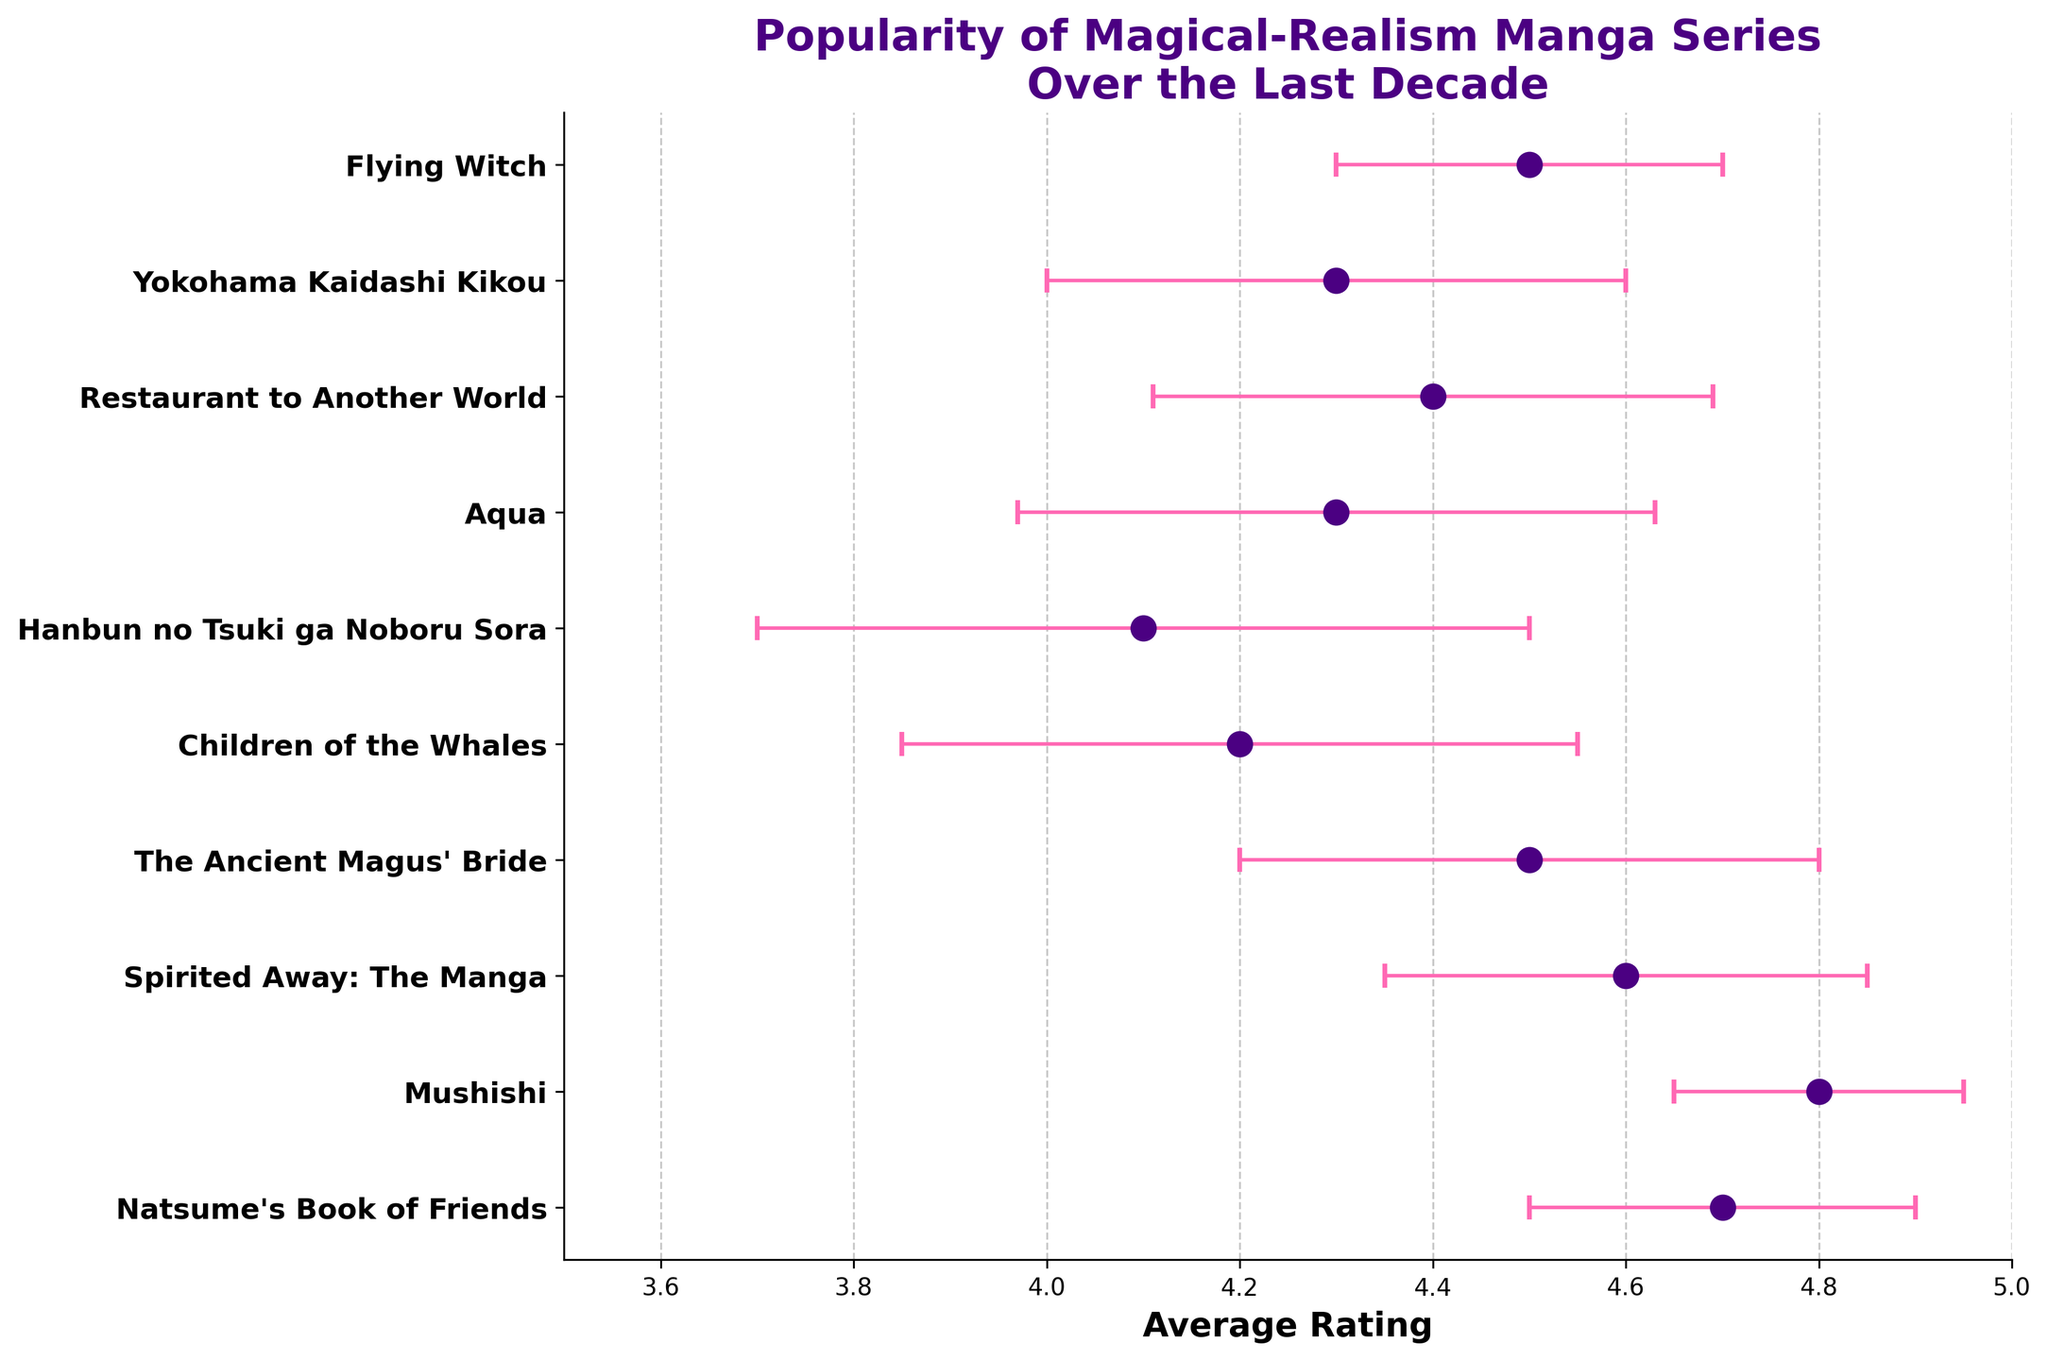How many manga series are featured in the figure? Count the number of series names listed along the y-axis. There are 10 manga series listed.
Answer: 10 What is the average rating for "Yokohama Kaidashi Kikou"? Refer to the dot corresponding to "Yokohama Kaidashi Kikou" on the y-axis and check the value on the x-axis. It shows an average rating of 4.3.
Answer: 4.3 Which manga has the highest average rating? Identify which dot is farthest to the right on the x-axis. "Mushishi" has the highest average rating, near 4.8.
Answer: "Mushishi" What is the difference in average rating between "Natsume's Book of Friends" and "Spirited Away: The Manga"? Find the x-axis values for "Natsume's Book of Friends" (4.7) and "Spirited Away: The Manga" (4.6). Subtract the lower from the higher value: 4.7 - 4.6 = 0.1.
Answer: 0.1 What is the standard deviation in ratings for "Children of the Whales"? Locate "Children of the Whales" on the y-axis and read its error bar's length along the x-axis. The standard deviation indicated is 0.35.
Answer: 0.35 How many series have an average rating of 4.5 or higher? Check which series' dots are located at 4.5 or more on the x-axis. "Natsume's Book of Friends," "Mushishi," "Spirited Away: The Manga," "The Ancient Magus' Bride," and "Flying Witch" qualify, making a total of 5 series.
Answer: 5 Which series has the largest standard deviation in its ratings? Identify which series' error bar extends the farthest. "Hanbun no Tsuki ga Noboru Sora" has the largest standard deviation of 0.4.
Answer: "Hanbun no Tsuki ga Noboru Sora" How does the popularity of "The Ancient Magus' Bride" compare to "Flying Witch" in terms of average rating and standard deviation? Identify their positions and error bars. "The Ancient Magus' Bride" has an average rating of 4.5 and a standard deviation of 0.3, while "Flying Witch" has the same average rating of 4.5 but a lower standard deviation of 0.2. Thus, they share the same average rating, but "The Ancient Magus' Bride" has a higher variability in ratings.
Answer: Both 4.5 average rating; "The Ancient Magus' Bride" has higher variability What is the range of average ratings for all series? Identify the highest and lowest average ratings. The highest is 4.8 (for "Mushishi"), and the lowest is 4.1 (for "Hanbun no Tsuki ga Noboru Sora"). The range is 4.8 - 4.1 = 0.7.
Answer: 0.7 